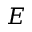Convert formula to latex. <formula><loc_0><loc_0><loc_500><loc_500>E</formula> 